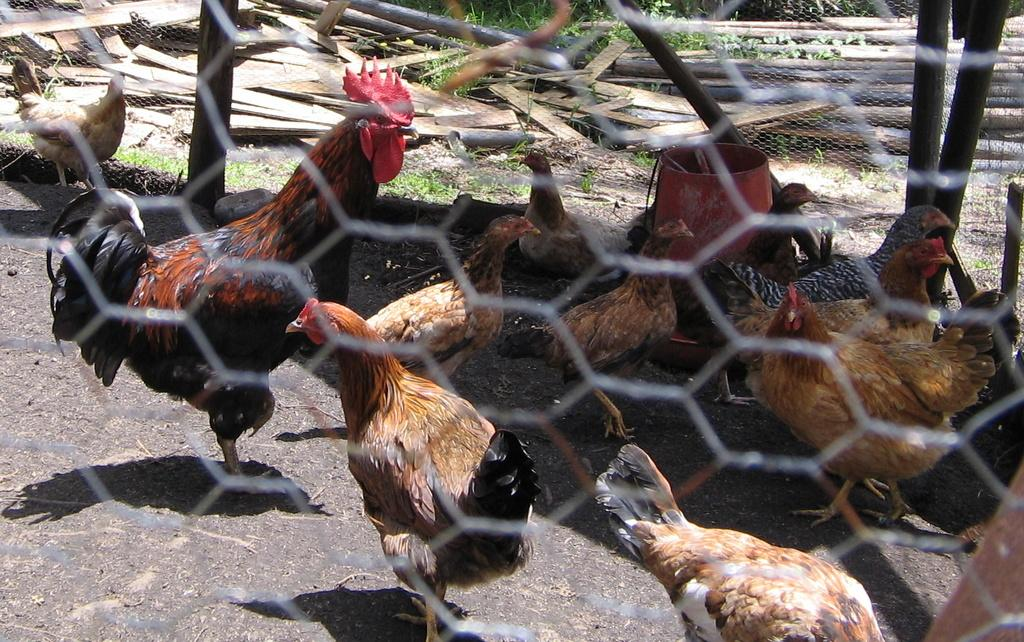What type of animals are in the image? There are hens in the image. What is the material of the mesh visible in the image? The mesh in the image is made of an unspecified material. What type of vegetation can be seen in the background of the image? There is grass in the background of the image. What type of material is present in the background of the image? There is wood in the background of the image. How many beads are scattered on the ground in the image? There are no beads present in the image. What type of frog can be seen hopping in the grass in the image? There is no frog present in the image; it only features hens and a mesh. 